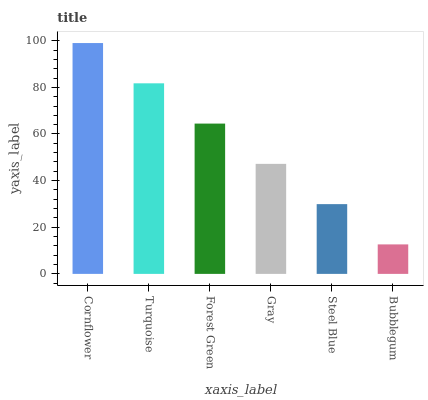Is Bubblegum the minimum?
Answer yes or no. Yes. Is Cornflower the maximum?
Answer yes or no. Yes. Is Turquoise the minimum?
Answer yes or no. No. Is Turquoise the maximum?
Answer yes or no. No. Is Cornflower greater than Turquoise?
Answer yes or no. Yes. Is Turquoise less than Cornflower?
Answer yes or no. Yes. Is Turquoise greater than Cornflower?
Answer yes or no. No. Is Cornflower less than Turquoise?
Answer yes or no. No. Is Forest Green the high median?
Answer yes or no. Yes. Is Gray the low median?
Answer yes or no. Yes. Is Cornflower the high median?
Answer yes or no. No. Is Bubblegum the low median?
Answer yes or no. No. 